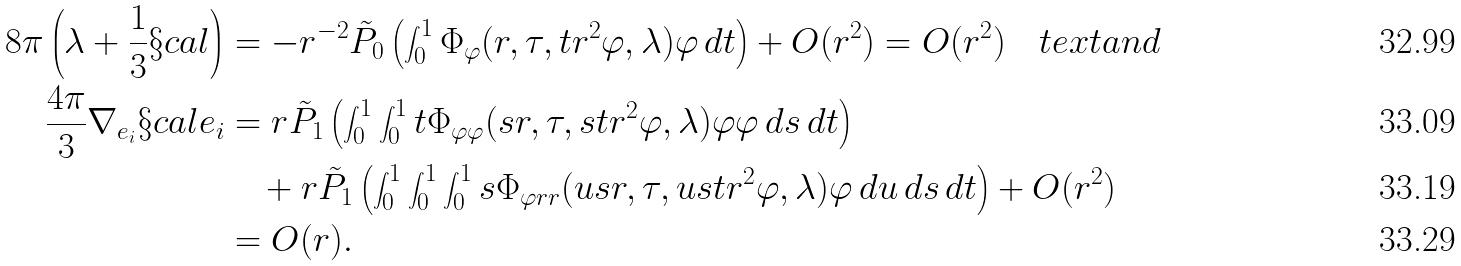Convert formula to latex. <formula><loc_0><loc_0><loc_500><loc_500>8 \pi \left ( \lambda + \frac { 1 } { 3 } \S c a l \right ) & = - r ^ { - 2 } \tilde { P } _ { 0 } \left ( \int _ { 0 } ^ { 1 } \Phi _ { \varphi } ( r , \tau , t r ^ { 2 } \varphi , \lambda ) \varphi \, d t \right ) + O ( r ^ { 2 } ) = O ( r ^ { 2 } ) \quad t e x t { a n d } \\ \frac { 4 \pi } { 3 } \nabla _ { e _ { i } } \S c a l e _ { i } & = r \tilde { P } _ { 1 } \left ( \int _ { 0 } ^ { 1 } \int _ { 0 } ^ { 1 } t \Phi _ { \varphi \varphi } ( s r , \tau , s t r ^ { 2 } \varphi , \lambda ) \varphi \varphi \, d s \, d t \right ) \\ & \quad + r \tilde { P } _ { 1 } \left ( \int _ { 0 } ^ { 1 } \int _ { 0 } ^ { 1 } \int _ { 0 } ^ { 1 } s \Phi _ { \varphi r r } ( u s r , \tau , u s t r ^ { 2 } \varphi , \lambda ) \varphi \, d u \, d s \, d t \right ) + O ( r ^ { 2 } ) \\ & = O ( r ) .</formula> 